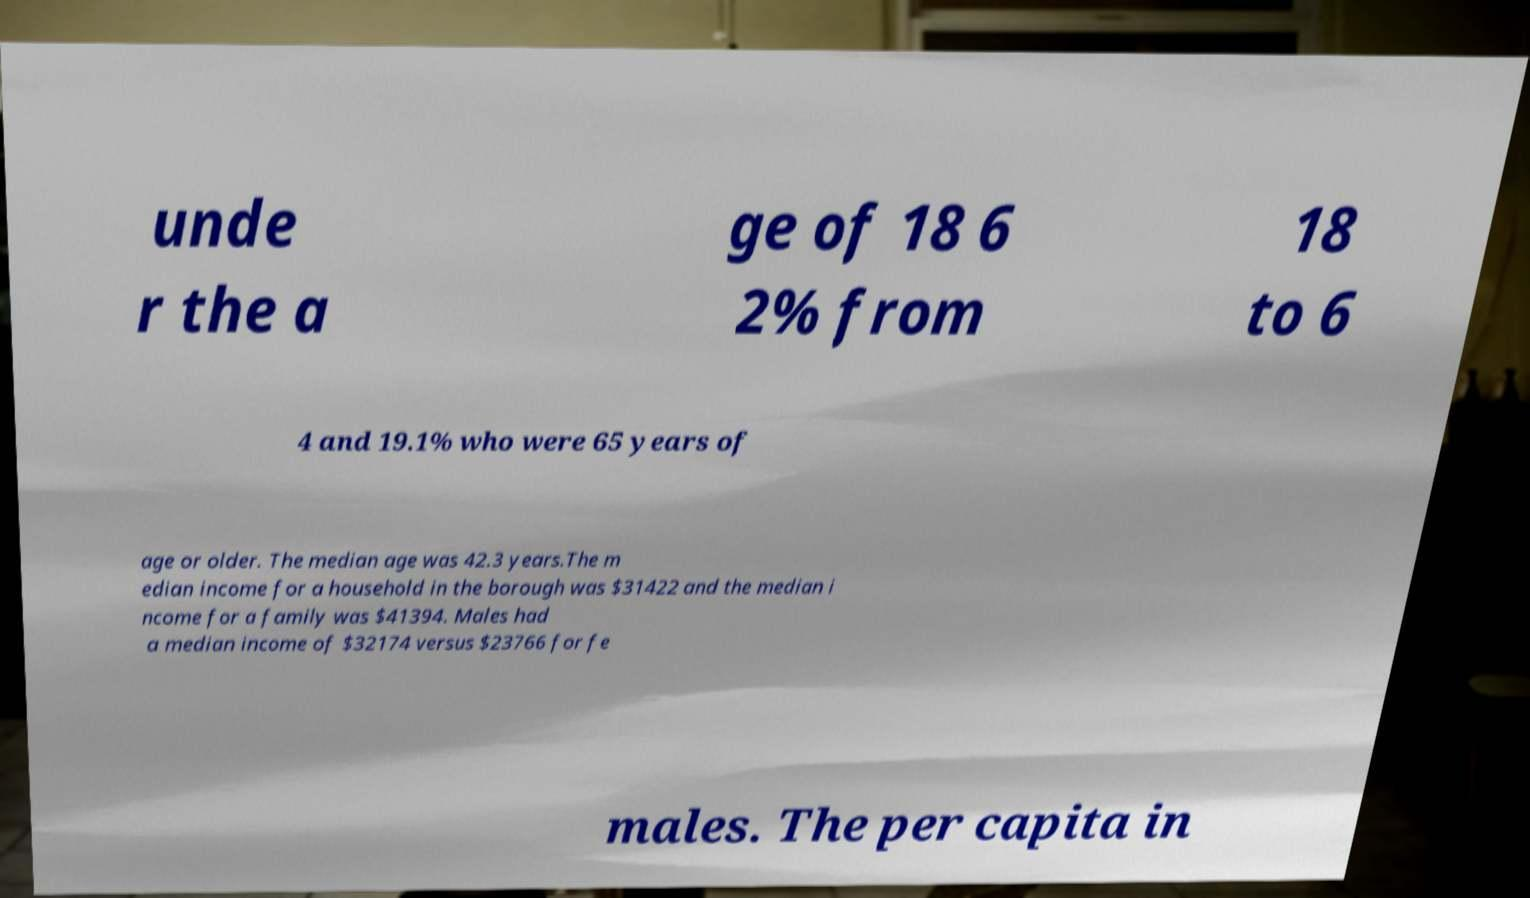What messages or text are displayed in this image? I need them in a readable, typed format. unde r the a ge of 18 6 2% from 18 to 6 4 and 19.1% who were 65 years of age or older. The median age was 42.3 years.The m edian income for a household in the borough was $31422 and the median i ncome for a family was $41394. Males had a median income of $32174 versus $23766 for fe males. The per capita in 